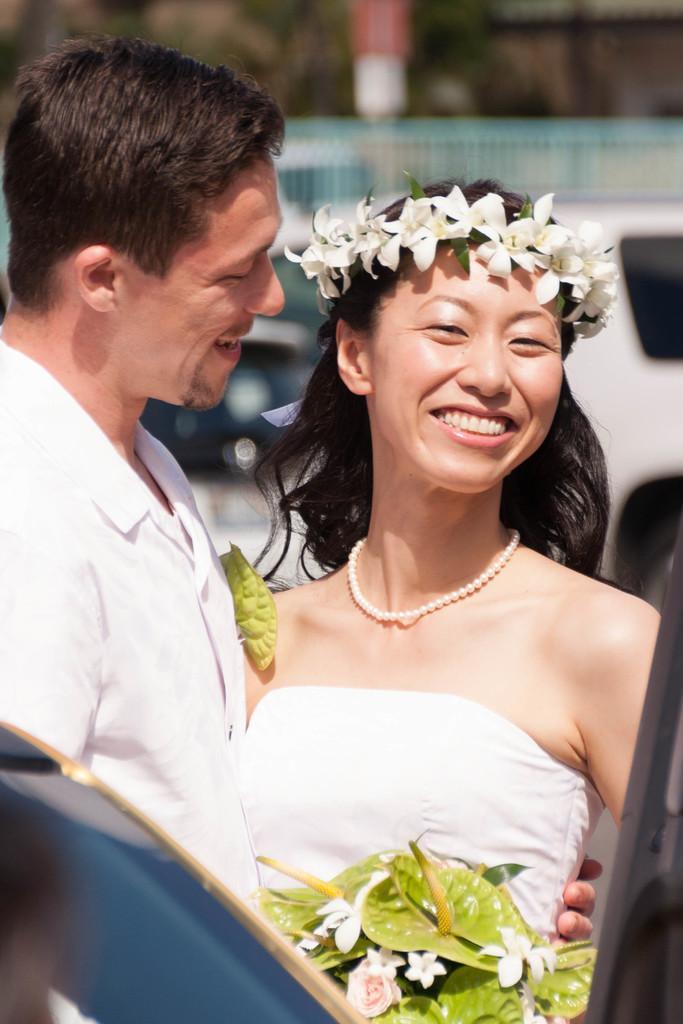Can you describe this image briefly? In this picture we can see a man and a woman smiling and in the background we can see vehicles, fence and it is blurry. 